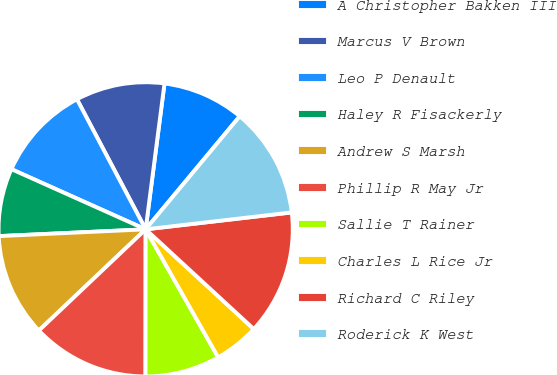Convert chart. <chart><loc_0><loc_0><loc_500><loc_500><pie_chart><fcel>A Christopher Bakken III<fcel>Marcus V Brown<fcel>Leo P Denault<fcel>Haley R Fisackerly<fcel>Andrew S Marsh<fcel>Phillip R May Jr<fcel>Sallie T Rainer<fcel>Charles L Rice Jr<fcel>Richard C Riley<fcel>Roderick K West<nl><fcel>9.0%<fcel>9.78%<fcel>10.56%<fcel>7.44%<fcel>11.34%<fcel>12.91%<fcel>8.22%<fcel>4.94%<fcel>13.69%<fcel>12.12%<nl></chart> 